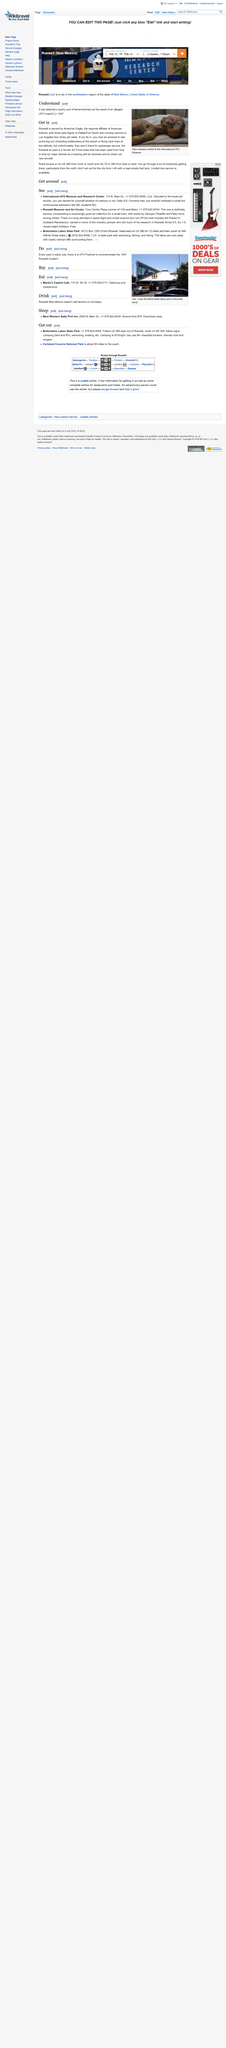Identify some key points in this picture. The article describes three locations. The Roswell Museum and Art Center has a wing dedicated to space flight and rocket science, which is a testament to the center's commitment to promoting the study and exploration of the final frontier. The image depicts an alien. The image was taken at the International UFO Museum. The event gained notoriety from an alleged UFO crash. 